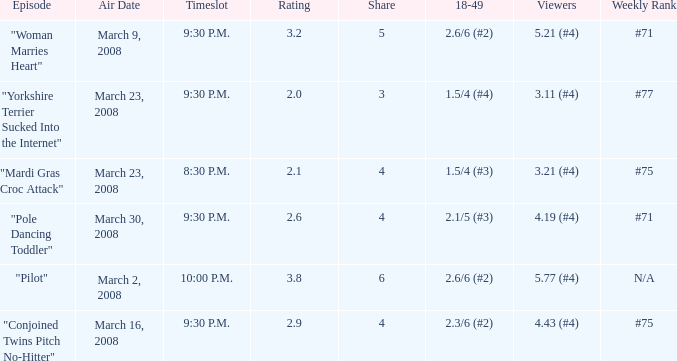What is the total ratings on share less than 4? 1.0. 